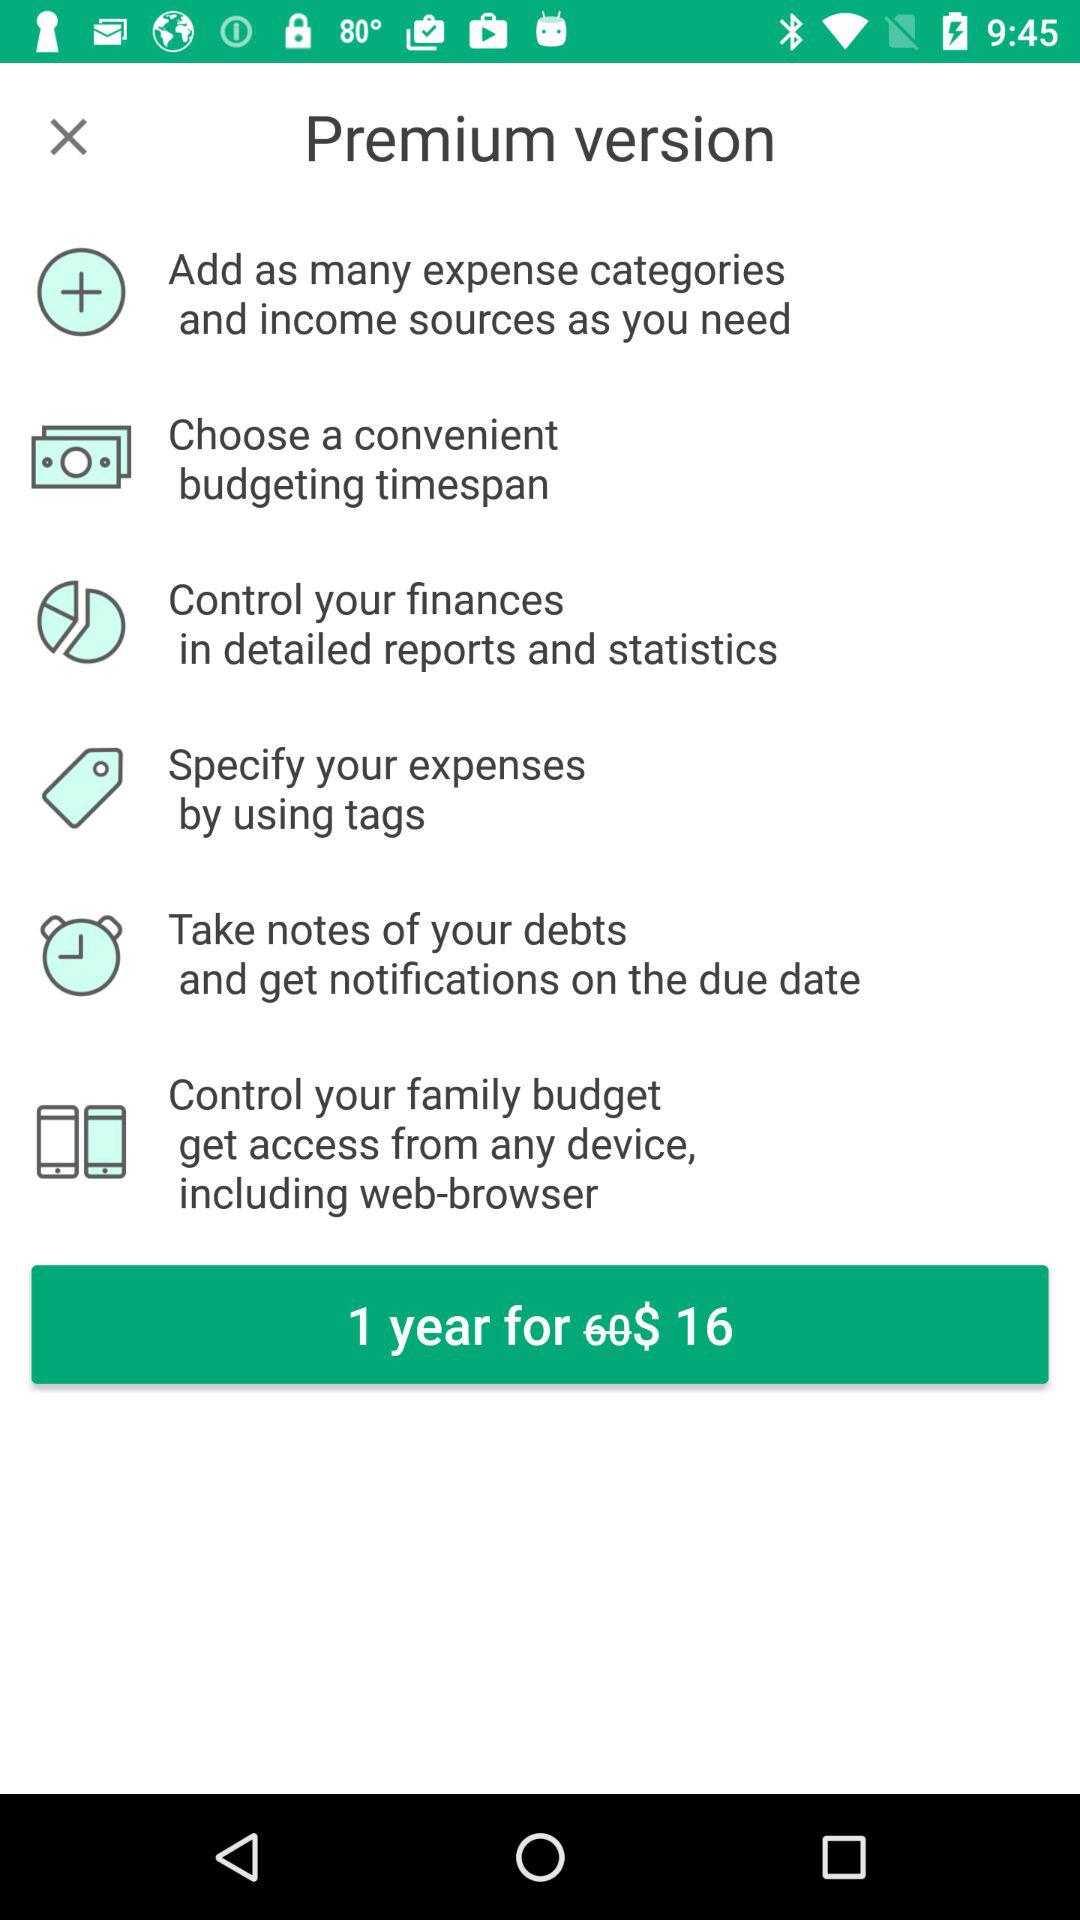How many features are there in the premium version?
Answer the question using a single word or phrase. 6 